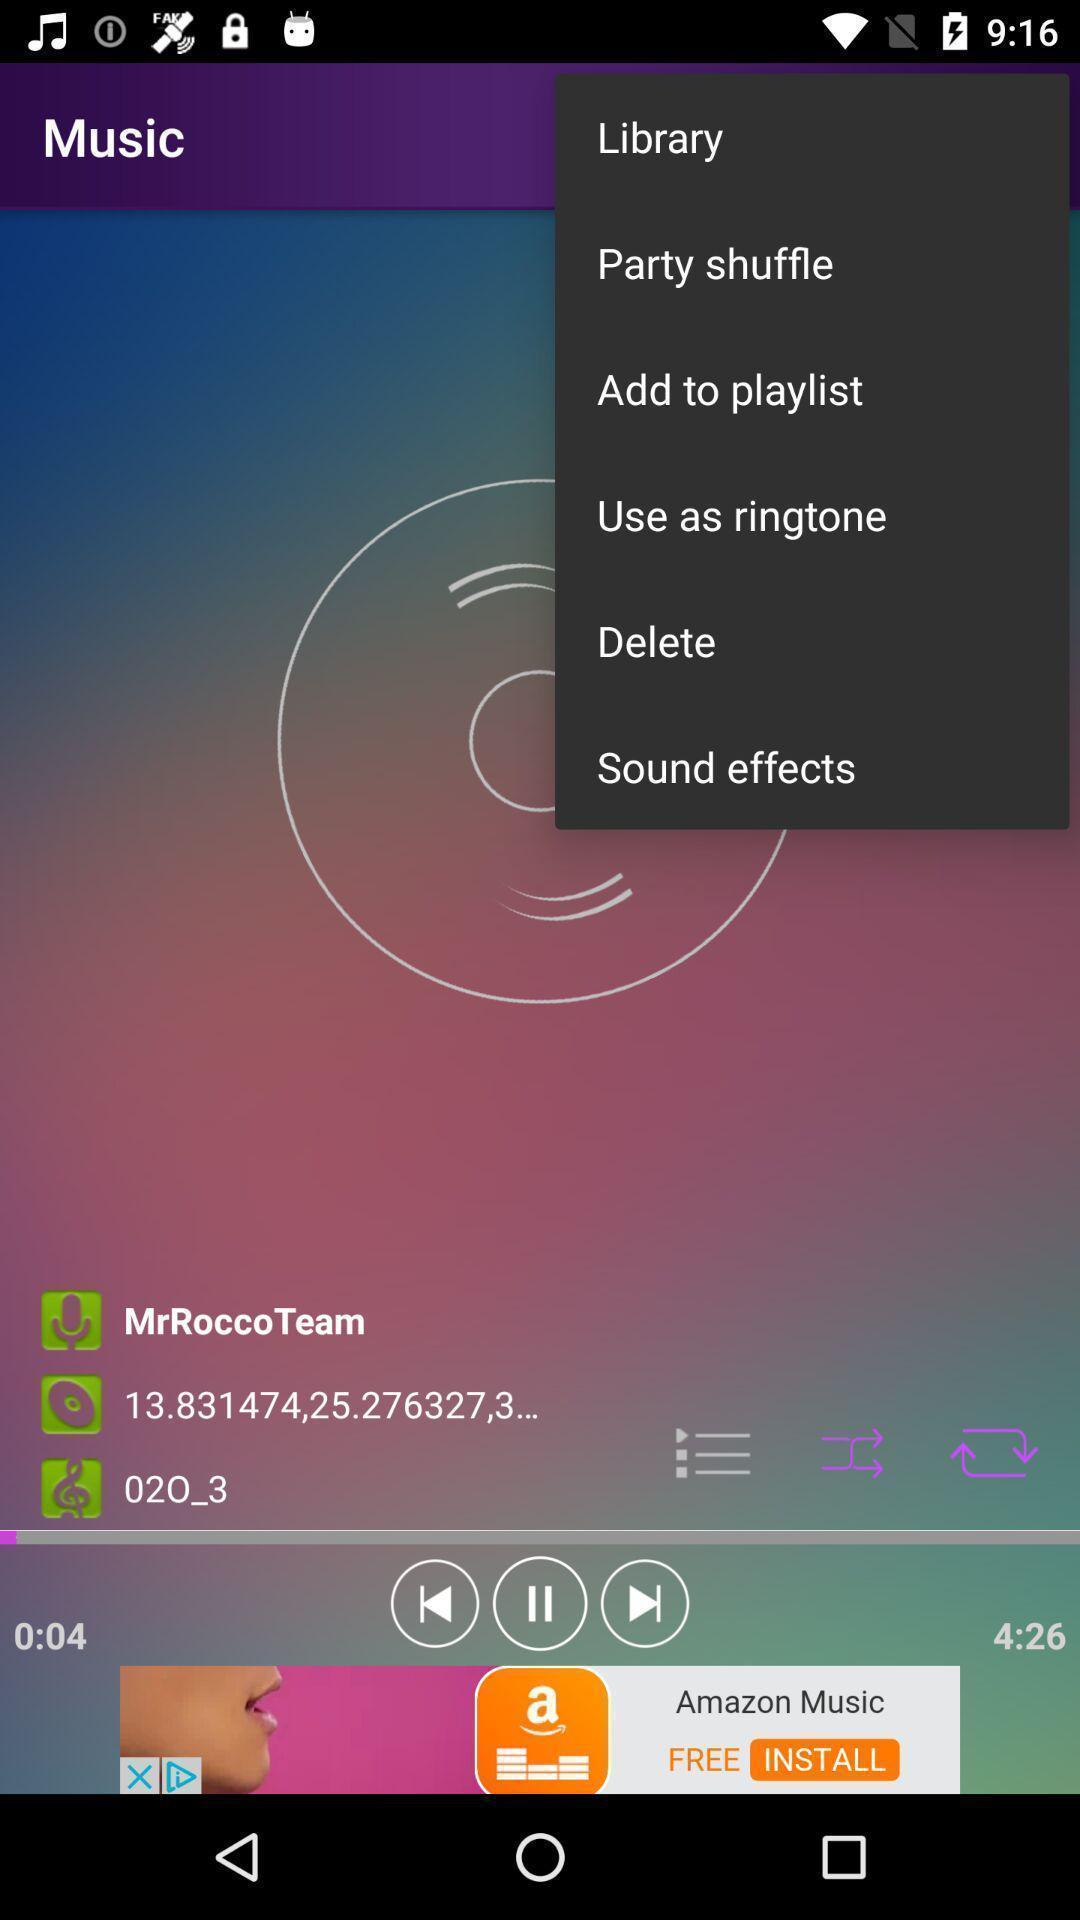Describe the key features of this screenshot. Page displays various options in music app. 